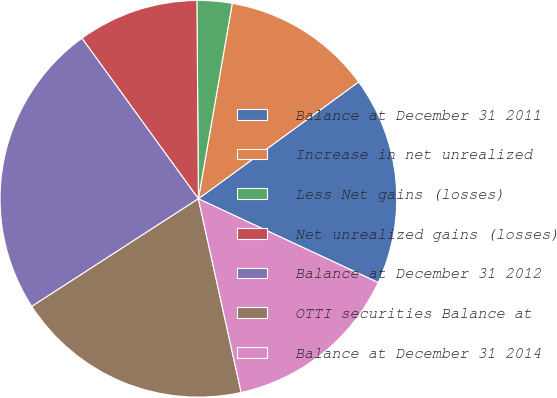<chart> <loc_0><loc_0><loc_500><loc_500><pie_chart><fcel>Balance at December 31 2011<fcel>Increase in net unrealized<fcel>Less Net gains (losses)<fcel>Net unrealized gains (losses)<fcel>Balance at December 31 2012<fcel>OTTI securities Balance at<fcel>Balance at December 31 2014<nl><fcel>16.97%<fcel>12.24%<fcel>2.85%<fcel>9.87%<fcel>24.14%<fcel>19.33%<fcel>14.6%<nl></chart> 